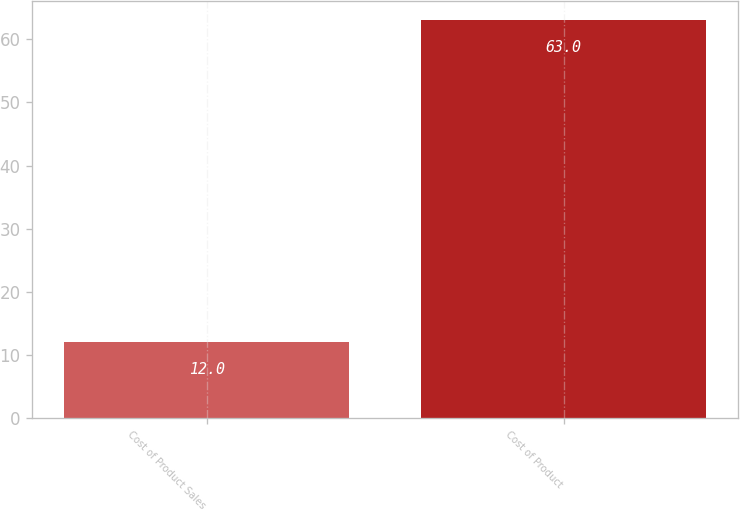Convert chart. <chart><loc_0><loc_0><loc_500><loc_500><bar_chart><fcel>Cost of Product Sales<fcel>Cost of Product<nl><fcel>12<fcel>63<nl></chart> 